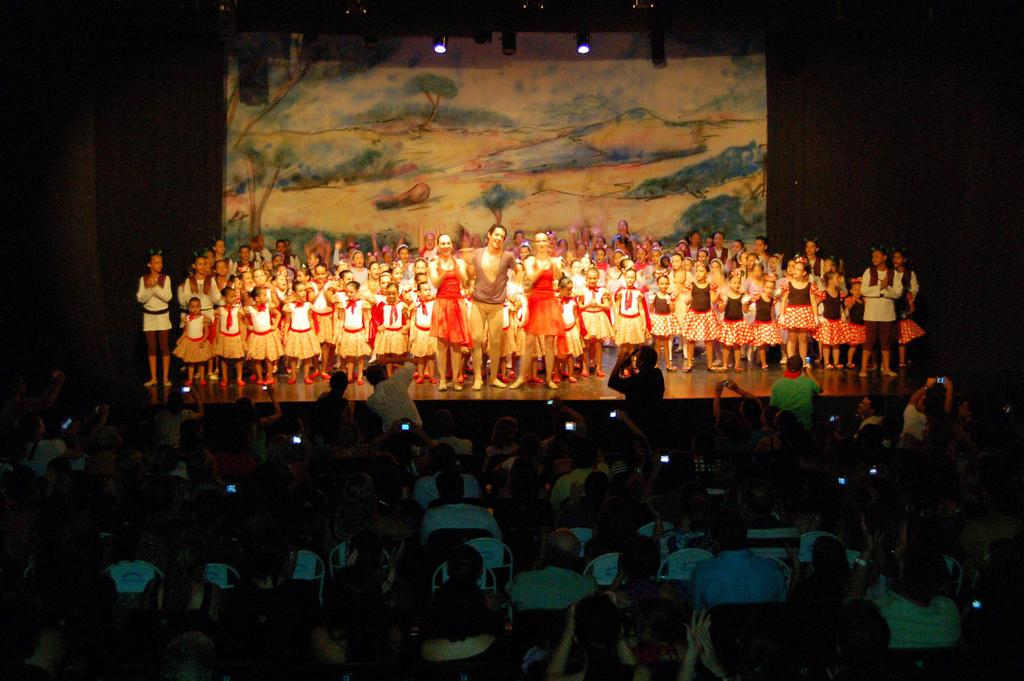What type of people can be seen on stage in the image? There are children and people on stage in the image. What can be seen in the background of the stage? There is a painting and focusing lights in the background. Who is present in the image besides the people on stage? There is an audience in the image. How are the audience members positioned in the image? The audience is sitting on chairs. What type of animals can be seen at the zoo in the image? There is no zoo or animals present in the image; it features a stage with people and an audience. What is the tendency of the chairs in the image? The chairs are not exhibiting any specific tendency; they are simply positioned for the audience to sit on. 